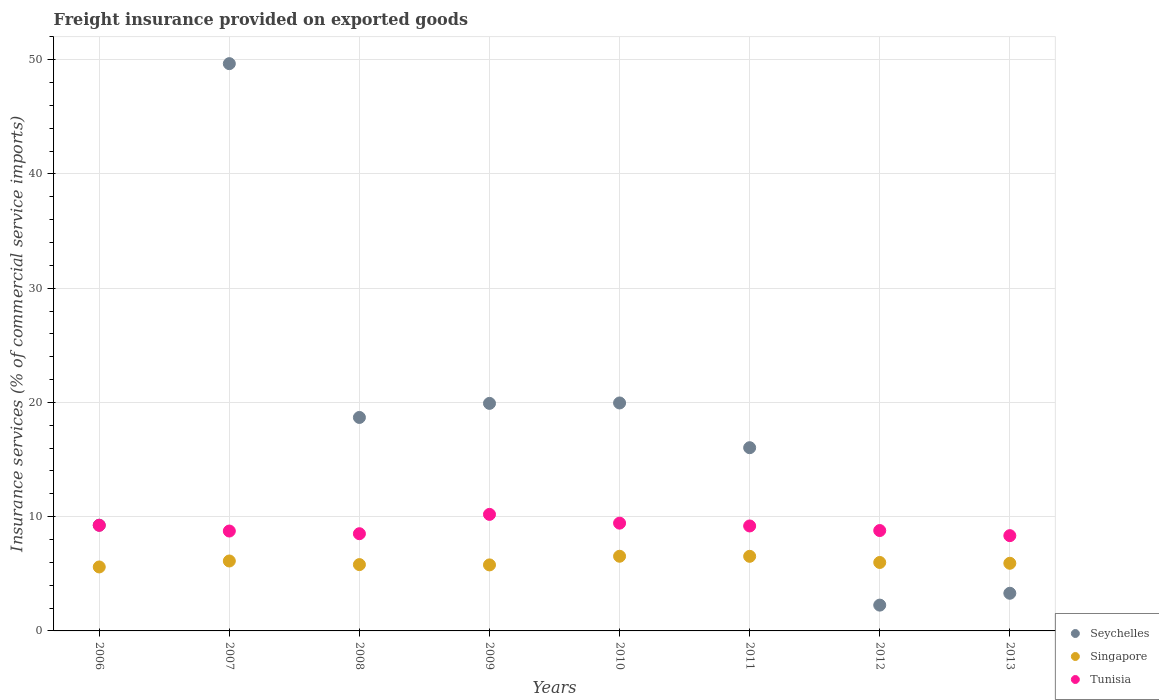How many different coloured dotlines are there?
Your answer should be very brief. 3. What is the freight insurance provided on exported goods in Singapore in 2008?
Provide a short and direct response. 5.81. Across all years, what is the maximum freight insurance provided on exported goods in Tunisia?
Offer a terse response. 10.2. Across all years, what is the minimum freight insurance provided on exported goods in Tunisia?
Offer a terse response. 8.34. What is the total freight insurance provided on exported goods in Singapore in the graph?
Your answer should be very brief. 48.29. What is the difference between the freight insurance provided on exported goods in Singapore in 2010 and that in 2011?
Offer a terse response. 0.01. What is the difference between the freight insurance provided on exported goods in Seychelles in 2011 and the freight insurance provided on exported goods in Singapore in 2010?
Offer a terse response. 9.5. What is the average freight insurance provided on exported goods in Tunisia per year?
Keep it short and to the point. 9.06. In the year 2012, what is the difference between the freight insurance provided on exported goods in Seychelles and freight insurance provided on exported goods in Tunisia?
Keep it short and to the point. -6.53. In how many years, is the freight insurance provided on exported goods in Singapore greater than 44 %?
Keep it short and to the point. 0. What is the ratio of the freight insurance provided on exported goods in Seychelles in 2007 to that in 2011?
Make the answer very short. 3.1. Is the freight insurance provided on exported goods in Seychelles in 2008 less than that in 2013?
Your answer should be very brief. No. Is the difference between the freight insurance provided on exported goods in Seychelles in 2006 and 2007 greater than the difference between the freight insurance provided on exported goods in Tunisia in 2006 and 2007?
Ensure brevity in your answer.  No. What is the difference between the highest and the second highest freight insurance provided on exported goods in Singapore?
Provide a succinct answer. 0.01. What is the difference between the highest and the lowest freight insurance provided on exported goods in Singapore?
Offer a terse response. 0.94. In how many years, is the freight insurance provided on exported goods in Tunisia greater than the average freight insurance provided on exported goods in Tunisia taken over all years?
Make the answer very short. 4. Is the sum of the freight insurance provided on exported goods in Singapore in 2009 and 2010 greater than the maximum freight insurance provided on exported goods in Seychelles across all years?
Provide a succinct answer. No. Does the freight insurance provided on exported goods in Seychelles monotonically increase over the years?
Provide a succinct answer. No. What is the difference between two consecutive major ticks on the Y-axis?
Provide a succinct answer. 10. Are the values on the major ticks of Y-axis written in scientific E-notation?
Your answer should be very brief. No. Does the graph contain grids?
Make the answer very short. Yes. How are the legend labels stacked?
Offer a very short reply. Vertical. What is the title of the graph?
Offer a terse response. Freight insurance provided on exported goods. Does "Curacao" appear as one of the legend labels in the graph?
Make the answer very short. No. What is the label or title of the X-axis?
Offer a very short reply. Years. What is the label or title of the Y-axis?
Your answer should be compact. Insurance services (% of commercial service imports). What is the Insurance services (% of commercial service imports) of Seychelles in 2006?
Provide a short and direct response. 9.26. What is the Insurance services (% of commercial service imports) of Singapore in 2006?
Your answer should be compact. 5.6. What is the Insurance services (% of commercial service imports) of Tunisia in 2006?
Provide a succinct answer. 9.25. What is the Insurance services (% of commercial service imports) in Seychelles in 2007?
Your response must be concise. 49.66. What is the Insurance services (% of commercial service imports) of Singapore in 2007?
Ensure brevity in your answer.  6.12. What is the Insurance services (% of commercial service imports) of Tunisia in 2007?
Offer a very short reply. 8.74. What is the Insurance services (% of commercial service imports) of Seychelles in 2008?
Give a very brief answer. 18.69. What is the Insurance services (% of commercial service imports) in Singapore in 2008?
Give a very brief answer. 5.81. What is the Insurance services (% of commercial service imports) of Tunisia in 2008?
Provide a succinct answer. 8.51. What is the Insurance services (% of commercial service imports) in Seychelles in 2009?
Your response must be concise. 19.92. What is the Insurance services (% of commercial service imports) in Singapore in 2009?
Keep it short and to the point. 5.78. What is the Insurance services (% of commercial service imports) of Tunisia in 2009?
Offer a terse response. 10.2. What is the Insurance services (% of commercial service imports) in Seychelles in 2010?
Your answer should be very brief. 19.96. What is the Insurance services (% of commercial service imports) in Singapore in 2010?
Make the answer very short. 6.54. What is the Insurance services (% of commercial service imports) of Tunisia in 2010?
Offer a terse response. 9.43. What is the Insurance services (% of commercial service imports) of Seychelles in 2011?
Offer a very short reply. 16.04. What is the Insurance services (% of commercial service imports) in Singapore in 2011?
Provide a succinct answer. 6.53. What is the Insurance services (% of commercial service imports) of Tunisia in 2011?
Provide a short and direct response. 9.19. What is the Insurance services (% of commercial service imports) of Seychelles in 2012?
Make the answer very short. 2.26. What is the Insurance services (% of commercial service imports) in Singapore in 2012?
Ensure brevity in your answer.  5.99. What is the Insurance services (% of commercial service imports) of Tunisia in 2012?
Provide a succinct answer. 8.79. What is the Insurance services (% of commercial service imports) of Seychelles in 2013?
Provide a succinct answer. 3.3. What is the Insurance services (% of commercial service imports) of Singapore in 2013?
Provide a succinct answer. 5.92. What is the Insurance services (% of commercial service imports) of Tunisia in 2013?
Give a very brief answer. 8.34. Across all years, what is the maximum Insurance services (% of commercial service imports) in Seychelles?
Make the answer very short. 49.66. Across all years, what is the maximum Insurance services (% of commercial service imports) of Singapore?
Make the answer very short. 6.54. Across all years, what is the maximum Insurance services (% of commercial service imports) in Tunisia?
Offer a very short reply. 10.2. Across all years, what is the minimum Insurance services (% of commercial service imports) of Seychelles?
Your answer should be very brief. 2.26. Across all years, what is the minimum Insurance services (% of commercial service imports) of Singapore?
Make the answer very short. 5.6. Across all years, what is the minimum Insurance services (% of commercial service imports) of Tunisia?
Your response must be concise. 8.34. What is the total Insurance services (% of commercial service imports) of Seychelles in the graph?
Ensure brevity in your answer.  139.08. What is the total Insurance services (% of commercial service imports) in Singapore in the graph?
Make the answer very short. 48.29. What is the total Insurance services (% of commercial service imports) in Tunisia in the graph?
Provide a succinct answer. 72.45. What is the difference between the Insurance services (% of commercial service imports) of Seychelles in 2006 and that in 2007?
Your answer should be very brief. -40.4. What is the difference between the Insurance services (% of commercial service imports) of Singapore in 2006 and that in 2007?
Provide a succinct answer. -0.52. What is the difference between the Insurance services (% of commercial service imports) of Tunisia in 2006 and that in 2007?
Offer a very short reply. 0.5. What is the difference between the Insurance services (% of commercial service imports) of Seychelles in 2006 and that in 2008?
Ensure brevity in your answer.  -9.43. What is the difference between the Insurance services (% of commercial service imports) of Singapore in 2006 and that in 2008?
Offer a very short reply. -0.21. What is the difference between the Insurance services (% of commercial service imports) in Tunisia in 2006 and that in 2008?
Provide a short and direct response. 0.74. What is the difference between the Insurance services (% of commercial service imports) of Seychelles in 2006 and that in 2009?
Offer a terse response. -10.66. What is the difference between the Insurance services (% of commercial service imports) in Singapore in 2006 and that in 2009?
Your answer should be very brief. -0.18. What is the difference between the Insurance services (% of commercial service imports) in Tunisia in 2006 and that in 2009?
Offer a very short reply. -0.96. What is the difference between the Insurance services (% of commercial service imports) in Seychelles in 2006 and that in 2010?
Provide a succinct answer. -10.7. What is the difference between the Insurance services (% of commercial service imports) in Singapore in 2006 and that in 2010?
Offer a very short reply. -0.94. What is the difference between the Insurance services (% of commercial service imports) of Tunisia in 2006 and that in 2010?
Make the answer very short. -0.19. What is the difference between the Insurance services (% of commercial service imports) of Seychelles in 2006 and that in 2011?
Ensure brevity in your answer.  -6.78. What is the difference between the Insurance services (% of commercial service imports) of Singapore in 2006 and that in 2011?
Your answer should be compact. -0.93. What is the difference between the Insurance services (% of commercial service imports) of Tunisia in 2006 and that in 2011?
Provide a succinct answer. 0.06. What is the difference between the Insurance services (% of commercial service imports) of Seychelles in 2006 and that in 2012?
Ensure brevity in your answer.  7. What is the difference between the Insurance services (% of commercial service imports) of Singapore in 2006 and that in 2012?
Your answer should be very brief. -0.39. What is the difference between the Insurance services (% of commercial service imports) of Tunisia in 2006 and that in 2012?
Make the answer very short. 0.46. What is the difference between the Insurance services (% of commercial service imports) of Seychelles in 2006 and that in 2013?
Offer a very short reply. 5.96. What is the difference between the Insurance services (% of commercial service imports) in Singapore in 2006 and that in 2013?
Your answer should be very brief. -0.32. What is the difference between the Insurance services (% of commercial service imports) of Tunisia in 2006 and that in 2013?
Keep it short and to the point. 0.91. What is the difference between the Insurance services (% of commercial service imports) of Seychelles in 2007 and that in 2008?
Your response must be concise. 30.97. What is the difference between the Insurance services (% of commercial service imports) in Singapore in 2007 and that in 2008?
Give a very brief answer. 0.32. What is the difference between the Insurance services (% of commercial service imports) of Tunisia in 2007 and that in 2008?
Keep it short and to the point. 0.23. What is the difference between the Insurance services (% of commercial service imports) in Seychelles in 2007 and that in 2009?
Your answer should be very brief. 29.74. What is the difference between the Insurance services (% of commercial service imports) of Singapore in 2007 and that in 2009?
Your answer should be compact. 0.34. What is the difference between the Insurance services (% of commercial service imports) in Tunisia in 2007 and that in 2009?
Make the answer very short. -1.46. What is the difference between the Insurance services (% of commercial service imports) of Seychelles in 2007 and that in 2010?
Ensure brevity in your answer.  29.7. What is the difference between the Insurance services (% of commercial service imports) of Singapore in 2007 and that in 2010?
Provide a succinct answer. -0.41. What is the difference between the Insurance services (% of commercial service imports) of Tunisia in 2007 and that in 2010?
Provide a succinct answer. -0.69. What is the difference between the Insurance services (% of commercial service imports) in Seychelles in 2007 and that in 2011?
Provide a succinct answer. 33.62. What is the difference between the Insurance services (% of commercial service imports) in Singapore in 2007 and that in 2011?
Offer a very short reply. -0.41. What is the difference between the Insurance services (% of commercial service imports) in Tunisia in 2007 and that in 2011?
Offer a terse response. -0.44. What is the difference between the Insurance services (% of commercial service imports) of Seychelles in 2007 and that in 2012?
Give a very brief answer. 47.4. What is the difference between the Insurance services (% of commercial service imports) in Singapore in 2007 and that in 2012?
Keep it short and to the point. 0.13. What is the difference between the Insurance services (% of commercial service imports) of Tunisia in 2007 and that in 2012?
Your answer should be very brief. -0.04. What is the difference between the Insurance services (% of commercial service imports) in Seychelles in 2007 and that in 2013?
Provide a succinct answer. 46.36. What is the difference between the Insurance services (% of commercial service imports) of Singapore in 2007 and that in 2013?
Make the answer very short. 0.2. What is the difference between the Insurance services (% of commercial service imports) of Tunisia in 2007 and that in 2013?
Your answer should be very brief. 0.4. What is the difference between the Insurance services (% of commercial service imports) in Seychelles in 2008 and that in 2009?
Provide a short and direct response. -1.23. What is the difference between the Insurance services (% of commercial service imports) of Singapore in 2008 and that in 2009?
Provide a succinct answer. 0.03. What is the difference between the Insurance services (% of commercial service imports) of Tunisia in 2008 and that in 2009?
Your response must be concise. -1.69. What is the difference between the Insurance services (% of commercial service imports) in Seychelles in 2008 and that in 2010?
Ensure brevity in your answer.  -1.27. What is the difference between the Insurance services (% of commercial service imports) of Singapore in 2008 and that in 2010?
Give a very brief answer. -0.73. What is the difference between the Insurance services (% of commercial service imports) of Tunisia in 2008 and that in 2010?
Your response must be concise. -0.92. What is the difference between the Insurance services (% of commercial service imports) in Seychelles in 2008 and that in 2011?
Your answer should be very brief. 2.65. What is the difference between the Insurance services (% of commercial service imports) of Singapore in 2008 and that in 2011?
Your answer should be very brief. -0.73. What is the difference between the Insurance services (% of commercial service imports) in Tunisia in 2008 and that in 2011?
Make the answer very short. -0.68. What is the difference between the Insurance services (% of commercial service imports) in Seychelles in 2008 and that in 2012?
Your answer should be compact. 16.43. What is the difference between the Insurance services (% of commercial service imports) of Singapore in 2008 and that in 2012?
Provide a succinct answer. -0.19. What is the difference between the Insurance services (% of commercial service imports) in Tunisia in 2008 and that in 2012?
Offer a terse response. -0.28. What is the difference between the Insurance services (% of commercial service imports) of Seychelles in 2008 and that in 2013?
Provide a succinct answer. 15.39. What is the difference between the Insurance services (% of commercial service imports) of Singapore in 2008 and that in 2013?
Provide a short and direct response. -0.12. What is the difference between the Insurance services (% of commercial service imports) of Tunisia in 2008 and that in 2013?
Give a very brief answer. 0.17. What is the difference between the Insurance services (% of commercial service imports) of Seychelles in 2009 and that in 2010?
Make the answer very short. -0.04. What is the difference between the Insurance services (% of commercial service imports) in Singapore in 2009 and that in 2010?
Your response must be concise. -0.76. What is the difference between the Insurance services (% of commercial service imports) of Tunisia in 2009 and that in 2010?
Keep it short and to the point. 0.77. What is the difference between the Insurance services (% of commercial service imports) of Seychelles in 2009 and that in 2011?
Ensure brevity in your answer.  3.88. What is the difference between the Insurance services (% of commercial service imports) of Singapore in 2009 and that in 2011?
Provide a succinct answer. -0.75. What is the difference between the Insurance services (% of commercial service imports) in Tunisia in 2009 and that in 2011?
Your response must be concise. 1.01. What is the difference between the Insurance services (% of commercial service imports) in Seychelles in 2009 and that in 2012?
Your answer should be compact. 17.66. What is the difference between the Insurance services (% of commercial service imports) of Singapore in 2009 and that in 2012?
Make the answer very short. -0.21. What is the difference between the Insurance services (% of commercial service imports) of Tunisia in 2009 and that in 2012?
Offer a terse response. 1.41. What is the difference between the Insurance services (% of commercial service imports) in Seychelles in 2009 and that in 2013?
Make the answer very short. 16.62. What is the difference between the Insurance services (% of commercial service imports) in Singapore in 2009 and that in 2013?
Make the answer very short. -0.14. What is the difference between the Insurance services (% of commercial service imports) of Tunisia in 2009 and that in 2013?
Your answer should be very brief. 1.86. What is the difference between the Insurance services (% of commercial service imports) of Seychelles in 2010 and that in 2011?
Ensure brevity in your answer.  3.92. What is the difference between the Insurance services (% of commercial service imports) in Singapore in 2010 and that in 2011?
Your response must be concise. 0.01. What is the difference between the Insurance services (% of commercial service imports) in Tunisia in 2010 and that in 2011?
Offer a terse response. 0.25. What is the difference between the Insurance services (% of commercial service imports) of Seychelles in 2010 and that in 2012?
Make the answer very short. 17.7. What is the difference between the Insurance services (% of commercial service imports) in Singapore in 2010 and that in 2012?
Give a very brief answer. 0.54. What is the difference between the Insurance services (% of commercial service imports) in Tunisia in 2010 and that in 2012?
Offer a very short reply. 0.65. What is the difference between the Insurance services (% of commercial service imports) in Seychelles in 2010 and that in 2013?
Your answer should be compact. 16.66. What is the difference between the Insurance services (% of commercial service imports) in Singapore in 2010 and that in 2013?
Offer a very short reply. 0.62. What is the difference between the Insurance services (% of commercial service imports) in Tunisia in 2010 and that in 2013?
Provide a succinct answer. 1.09. What is the difference between the Insurance services (% of commercial service imports) in Seychelles in 2011 and that in 2012?
Your response must be concise. 13.78. What is the difference between the Insurance services (% of commercial service imports) of Singapore in 2011 and that in 2012?
Offer a terse response. 0.54. What is the difference between the Insurance services (% of commercial service imports) of Tunisia in 2011 and that in 2012?
Make the answer very short. 0.4. What is the difference between the Insurance services (% of commercial service imports) of Seychelles in 2011 and that in 2013?
Offer a very short reply. 12.74. What is the difference between the Insurance services (% of commercial service imports) of Singapore in 2011 and that in 2013?
Provide a succinct answer. 0.61. What is the difference between the Insurance services (% of commercial service imports) in Tunisia in 2011 and that in 2013?
Ensure brevity in your answer.  0.85. What is the difference between the Insurance services (% of commercial service imports) of Seychelles in 2012 and that in 2013?
Your answer should be very brief. -1.04. What is the difference between the Insurance services (% of commercial service imports) of Singapore in 2012 and that in 2013?
Offer a terse response. 0.07. What is the difference between the Insurance services (% of commercial service imports) of Tunisia in 2012 and that in 2013?
Keep it short and to the point. 0.45. What is the difference between the Insurance services (% of commercial service imports) in Seychelles in 2006 and the Insurance services (% of commercial service imports) in Singapore in 2007?
Your answer should be very brief. 3.13. What is the difference between the Insurance services (% of commercial service imports) of Seychelles in 2006 and the Insurance services (% of commercial service imports) of Tunisia in 2007?
Offer a very short reply. 0.51. What is the difference between the Insurance services (% of commercial service imports) in Singapore in 2006 and the Insurance services (% of commercial service imports) in Tunisia in 2007?
Offer a terse response. -3.14. What is the difference between the Insurance services (% of commercial service imports) of Seychelles in 2006 and the Insurance services (% of commercial service imports) of Singapore in 2008?
Offer a terse response. 3.45. What is the difference between the Insurance services (% of commercial service imports) of Seychelles in 2006 and the Insurance services (% of commercial service imports) of Tunisia in 2008?
Give a very brief answer. 0.75. What is the difference between the Insurance services (% of commercial service imports) in Singapore in 2006 and the Insurance services (% of commercial service imports) in Tunisia in 2008?
Offer a terse response. -2.91. What is the difference between the Insurance services (% of commercial service imports) of Seychelles in 2006 and the Insurance services (% of commercial service imports) of Singapore in 2009?
Make the answer very short. 3.48. What is the difference between the Insurance services (% of commercial service imports) of Seychelles in 2006 and the Insurance services (% of commercial service imports) of Tunisia in 2009?
Give a very brief answer. -0.95. What is the difference between the Insurance services (% of commercial service imports) in Singapore in 2006 and the Insurance services (% of commercial service imports) in Tunisia in 2009?
Ensure brevity in your answer.  -4.6. What is the difference between the Insurance services (% of commercial service imports) of Seychelles in 2006 and the Insurance services (% of commercial service imports) of Singapore in 2010?
Your answer should be very brief. 2.72. What is the difference between the Insurance services (% of commercial service imports) of Seychelles in 2006 and the Insurance services (% of commercial service imports) of Tunisia in 2010?
Your response must be concise. -0.18. What is the difference between the Insurance services (% of commercial service imports) in Singapore in 2006 and the Insurance services (% of commercial service imports) in Tunisia in 2010?
Keep it short and to the point. -3.84. What is the difference between the Insurance services (% of commercial service imports) of Seychelles in 2006 and the Insurance services (% of commercial service imports) of Singapore in 2011?
Provide a short and direct response. 2.73. What is the difference between the Insurance services (% of commercial service imports) of Seychelles in 2006 and the Insurance services (% of commercial service imports) of Tunisia in 2011?
Offer a terse response. 0.07. What is the difference between the Insurance services (% of commercial service imports) in Singapore in 2006 and the Insurance services (% of commercial service imports) in Tunisia in 2011?
Make the answer very short. -3.59. What is the difference between the Insurance services (% of commercial service imports) of Seychelles in 2006 and the Insurance services (% of commercial service imports) of Singapore in 2012?
Your answer should be very brief. 3.26. What is the difference between the Insurance services (% of commercial service imports) in Seychelles in 2006 and the Insurance services (% of commercial service imports) in Tunisia in 2012?
Your response must be concise. 0.47. What is the difference between the Insurance services (% of commercial service imports) of Singapore in 2006 and the Insurance services (% of commercial service imports) of Tunisia in 2012?
Offer a terse response. -3.19. What is the difference between the Insurance services (% of commercial service imports) in Seychelles in 2006 and the Insurance services (% of commercial service imports) in Singapore in 2013?
Your answer should be very brief. 3.33. What is the difference between the Insurance services (% of commercial service imports) in Seychelles in 2006 and the Insurance services (% of commercial service imports) in Tunisia in 2013?
Give a very brief answer. 0.92. What is the difference between the Insurance services (% of commercial service imports) in Singapore in 2006 and the Insurance services (% of commercial service imports) in Tunisia in 2013?
Offer a very short reply. -2.74. What is the difference between the Insurance services (% of commercial service imports) of Seychelles in 2007 and the Insurance services (% of commercial service imports) of Singapore in 2008?
Give a very brief answer. 43.85. What is the difference between the Insurance services (% of commercial service imports) in Seychelles in 2007 and the Insurance services (% of commercial service imports) in Tunisia in 2008?
Provide a succinct answer. 41.15. What is the difference between the Insurance services (% of commercial service imports) in Singapore in 2007 and the Insurance services (% of commercial service imports) in Tunisia in 2008?
Your response must be concise. -2.39. What is the difference between the Insurance services (% of commercial service imports) of Seychelles in 2007 and the Insurance services (% of commercial service imports) of Singapore in 2009?
Give a very brief answer. 43.88. What is the difference between the Insurance services (% of commercial service imports) of Seychelles in 2007 and the Insurance services (% of commercial service imports) of Tunisia in 2009?
Provide a short and direct response. 39.46. What is the difference between the Insurance services (% of commercial service imports) of Singapore in 2007 and the Insurance services (% of commercial service imports) of Tunisia in 2009?
Your answer should be compact. -4.08. What is the difference between the Insurance services (% of commercial service imports) of Seychelles in 2007 and the Insurance services (% of commercial service imports) of Singapore in 2010?
Make the answer very short. 43.12. What is the difference between the Insurance services (% of commercial service imports) in Seychelles in 2007 and the Insurance services (% of commercial service imports) in Tunisia in 2010?
Provide a short and direct response. 40.23. What is the difference between the Insurance services (% of commercial service imports) in Singapore in 2007 and the Insurance services (% of commercial service imports) in Tunisia in 2010?
Keep it short and to the point. -3.31. What is the difference between the Insurance services (% of commercial service imports) in Seychelles in 2007 and the Insurance services (% of commercial service imports) in Singapore in 2011?
Your answer should be compact. 43.13. What is the difference between the Insurance services (% of commercial service imports) in Seychelles in 2007 and the Insurance services (% of commercial service imports) in Tunisia in 2011?
Make the answer very short. 40.47. What is the difference between the Insurance services (% of commercial service imports) of Singapore in 2007 and the Insurance services (% of commercial service imports) of Tunisia in 2011?
Provide a short and direct response. -3.07. What is the difference between the Insurance services (% of commercial service imports) of Seychelles in 2007 and the Insurance services (% of commercial service imports) of Singapore in 2012?
Your answer should be very brief. 43.67. What is the difference between the Insurance services (% of commercial service imports) of Seychelles in 2007 and the Insurance services (% of commercial service imports) of Tunisia in 2012?
Give a very brief answer. 40.87. What is the difference between the Insurance services (% of commercial service imports) of Singapore in 2007 and the Insurance services (% of commercial service imports) of Tunisia in 2012?
Your answer should be very brief. -2.67. What is the difference between the Insurance services (% of commercial service imports) in Seychelles in 2007 and the Insurance services (% of commercial service imports) in Singapore in 2013?
Your answer should be compact. 43.74. What is the difference between the Insurance services (% of commercial service imports) in Seychelles in 2007 and the Insurance services (% of commercial service imports) in Tunisia in 2013?
Offer a terse response. 41.32. What is the difference between the Insurance services (% of commercial service imports) in Singapore in 2007 and the Insurance services (% of commercial service imports) in Tunisia in 2013?
Your answer should be compact. -2.22. What is the difference between the Insurance services (% of commercial service imports) of Seychelles in 2008 and the Insurance services (% of commercial service imports) of Singapore in 2009?
Provide a short and direct response. 12.91. What is the difference between the Insurance services (% of commercial service imports) in Seychelles in 2008 and the Insurance services (% of commercial service imports) in Tunisia in 2009?
Make the answer very short. 8.49. What is the difference between the Insurance services (% of commercial service imports) of Singapore in 2008 and the Insurance services (% of commercial service imports) of Tunisia in 2009?
Keep it short and to the point. -4.4. What is the difference between the Insurance services (% of commercial service imports) of Seychelles in 2008 and the Insurance services (% of commercial service imports) of Singapore in 2010?
Your answer should be very brief. 12.15. What is the difference between the Insurance services (% of commercial service imports) of Seychelles in 2008 and the Insurance services (% of commercial service imports) of Tunisia in 2010?
Your answer should be very brief. 9.25. What is the difference between the Insurance services (% of commercial service imports) of Singapore in 2008 and the Insurance services (% of commercial service imports) of Tunisia in 2010?
Ensure brevity in your answer.  -3.63. What is the difference between the Insurance services (% of commercial service imports) in Seychelles in 2008 and the Insurance services (% of commercial service imports) in Singapore in 2011?
Your response must be concise. 12.16. What is the difference between the Insurance services (% of commercial service imports) of Seychelles in 2008 and the Insurance services (% of commercial service imports) of Tunisia in 2011?
Your answer should be very brief. 9.5. What is the difference between the Insurance services (% of commercial service imports) of Singapore in 2008 and the Insurance services (% of commercial service imports) of Tunisia in 2011?
Your answer should be compact. -3.38. What is the difference between the Insurance services (% of commercial service imports) in Seychelles in 2008 and the Insurance services (% of commercial service imports) in Singapore in 2012?
Keep it short and to the point. 12.7. What is the difference between the Insurance services (% of commercial service imports) of Seychelles in 2008 and the Insurance services (% of commercial service imports) of Tunisia in 2012?
Give a very brief answer. 9.9. What is the difference between the Insurance services (% of commercial service imports) in Singapore in 2008 and the Insurance services (% of commercial service imports) in Tunisia in 2012?
Offer a very short reply. -2.98. What is the difference between the Insurance services (% of commercial service imports) of Seychelles in 2008 and the Insurance services (% of commercial service imports) of Singapore in 2013?
Your response must be concise. 12.77. What is the difference between the Insurance services (% of commercial service imports) of Seychelles in 2008 and the Insurance services (% of commercial service imports) of Tunisia in 2013?
Provide a succinct answer. 10.35. What is the difference between the Insurance services (% of commercial service imports) of Singapore in 2008 and the Insurance services (% of commercial service imports) of Tunisia in 2013?
Your response must be concise. -2.53. What is the difference between the Insurance services (% of commercial service imports) of Seychelles in 2009 and the Insurance services (% of commercial service imports) of Singapore in 2010?
Ensure brevity in your answer.  13.38. What is the difference between the Insurance services (% of commercial service imports) in Seychelles in 2009 and the Insurance services (% of commercial service imports) in Tunisia in 2010?
Your answer should be very brief. 10.48. What is the difference between the Insurance services (% of commercial service imports) of Singapore in 2009 and the Insurance services (% of commercial service imports) of Tunisia in 2010?
Offer a terse response. -3.66. What is the difference between the Insurance services (% of commercial service imports) of Seychelles in 2009 and the Insurance services (% of commercial service imports) of Singapore in 2011?
Give a very brief answer. 13.39. What is the difference between the Insurance services (% of commercial service imports) of Seychelles in 2009 and the Insurance services (% of commercial service imports) of Tunisia in 2011?
Offer a terse response. 10.73. What is the difference between the Insurance services (% of commercial service imports) in Singapore in 2009 and the Insurance services (% of commercial service imports) in Tunisia in 2011?
Keep it short and to the point. -3.41. What is the difference between the Insurance services (% of commercial service imports) in Seychelles in 2009 and the Insurance services (% of commercial service imports) in Singapore in 2012?
Your response must be concise. 13.93. What is the difference between the Insurance services (% of commercial service imports) of Seychelles in 2009 and the Insurance services (% of commercial service imports) of Tunisia in 2012?
Offer a very short reply. 11.13. What is the difference between the Insurance services (% of commercial service imports) of Singapore in 2009 and the Insurance services (% of commercial service imports) of Tunisia in 2012?
Provide a short and direct response. -3.01. What is the difference between the Insurance services (% of commercial service imports) in Seychelles in 2009 and the Insurance services (% of commercial service imports) in Singapore in 2013?
Provide a short and direct response. 14. What is the difference between the Insurance services (% of commercial service imports) of Seychelles in 2009 and the Insurance services (% of commercial service imports) of Tunisia in 2013?
Provide a short and direct response. 11.58. What is the difference between the Insurance services (% of commercial service imports) in Singapore in 2009 and the Insurance services (% of commercial service imports) in Tunisia in 2013?
Keep it short and to the point. -2.56. What is the difference between the Insurance services (% of commercial service imports) of Seychelles in 2010 and the Insurance services (% of commercial service imports) of Singapore in 2011?
Make the answer very short. 13.43. What is the difference between the Insurance services (% of commercial service imports) in Seychelles in 2010 and the Insurance services (% of commercial service imports) in Tunisia in 2011?
Make the answer very short. 10.77. What is the difference between the Insurance services (% of commercial service imports) of Singapore in 2010 and the Insurance services (% of commercial service imports) of Tunisia in 2011?
Give a very brief answer. -2.65. What is the difference between the Insurance services (% of commercial service imports) of Seychelles in 2010 and the Insurance services (% of commercial service imports) of Singapore in 2012?
Ensure brevity in your answer.  13.96. What is the difference between the Insurance services (% of commercial service imports) in Seychelles in 2010 and the Insurance services (% of commercial service imports) in Tunisia in 2012?
Provide a short and direct response. 11.17. What is the difference between the Insurance services (% of commercial service imports) of Singapore in 2010 and the Insurance services (% of commercial service imports) of Tunisia in 2012?
Give a very brief answer. -2.25. What is the difference between the Insurance services (% of commercial service imports) of Seychelles in 2010 and the Insurance services (% of commercial service imports) of Singapore in 2013?
Your answer should be compact. 14.03. What is the difference between the Insurance services (% of commercial service imports) of Seychelles in 2010 and the Insurance services (% of commercial service imports) of Tunisia in 2013?
Offer a very short reply. 11.62. What is the difference between the Insurance services (% of commercial service imports) of Singapore in 2010 and the Insurance services (% of commercial service imports) of Tunisia in 2013?
Your answer should be very brief. -1.8. What is the difference between the Insurance services (% of commercial service imports) of Seychelles in 2011 and the Insurance services (% of commercial service imports) of Singapore in 2012?
Provide a short and direct response. 10.05. What is the difference between the Insurance services (% of commercial service imports) of Seychelles in 2011 and the Insurance services (% of commercial service imports) of Tunisia in 2012?
Give a very brief answer. 7.25. What is the difference between the Insurance services (% of commercial service imports) of Singapore in 2011 and the Insurance services (% of commercial service imports) of Tunisia in 2012?
Give a very brief answer. -2.26. What is the difference between the Insurance services (% of commercial service imports) of Seychelles in 2011 and the Insurance services (% of commercial service imports) of Singapore in 2013?
Offer a terse response. 10.12. What is the difference between the Insurance services (% of commercial service imports) of Seychelles in 2011 and the Insurance services (% of commercial service imports) of Tunisia in 2013?
Ensure brevity in your answer.  7.7. What is the difference between the Insurance services (% of commercial service imports) of Singapore in 2011 and the Insurance services (% of commercial service imports) of Tunisia in 2013?
Make the answer very short. -1.81. What is the difference between the Insurance services (% of commercial service imports) of Seychelles in 2012 and the Insurance services (% of commercial service imports) of Singapore in 2013?
Ensure brevity in your answer.  -3.66. What is the difference between the Insurance services (% of commercial service imports) in Seychelles in 2012 and the Insurance services (% of commercial service imports) in Tunisia in 2013?
Your answer should be very brief. -6.08. What is the difference between the Insurance services (% of commercial service imports) of Singapore in 2012 and the Insurance services (% of commercial service imports) of Tunisia in 2013?
Ensure brevity in your answer.  -2.35. What is the average Insurance services (% of commercial service imports) in Seychelles per year?
Ensure brevity in your answer.  17.38. What is the average Insurance services (% of commercial service imports) in Singapore per year?
Your answer should be compact. 6.04. What is the average Insurance services (% of commercial service imports) of Tunisia per year?
Offer a very short reply. 9.06. In the year 2006, what is the difference between the Insurance services (% of commercial service imports) in Seychelles and Insurance services (% of commercial service imports) in Singapore?
Offer a terse response. 3.66. In the year 2006, what is the difference between the Insurance services (% of commercial service imports) in Seychelles and Insurance services (% of commercial service imports) in Tunisia?
Your response must be concise. 0.01. In the year 2006, what is the difference between the Insurance services (% of commercial service imports) of Singapore and Insurance services (% of commercial service imports) of Tunisia?
Keep it short and to the point. -3.65. In the year 2007, what is the difference between the Insurance services (% of commercial service imports) in Seychelles and Insurance services (% of commercial service imports) in Singapore?
Your response must be concise. 43.54. In the year 2007, what is the difference between the Insurance services (% of commercial service imports) of Seychelles and Insurance services (% of commercial service imports) of Tunisia?
Provide a succinct answer. 40.92. In the year 2007, what is the difference between the Insurance services (% of commercial service imports) of Singapore and Insurance services (% of commercial service imports) of Tunisia?
Provide a succinct answer. -2.62. In the year 2008, what is the difference between the Insurance services (% of commercial service imports) in Seychelles and Insurance services (% of commercial service imports) in Singapore?
Your response must be concise. 12.88. In the year 2008, what is the difference between the Insurance services (% of commercial service imports) in Seychelles and Insurance services (% of commercial service imports) in Tunisia?
Make the answer very short. 10.18. In the year 2008, what is the difference between the Insurance services (% of commercial service imports) in Singapore and Insurance services (% of commercial service imports) in Tunisia?
Ensure brevity in your answer.  -2.7. In the year 2009, what is the difference between the Insurance services (% of commercial service imports) in Seychelles and Insurance services (% of commercial service imports) in Singapore?
Ensure brevity in your answer.  14.14. In the year 2009, what is the difference between the Insurance services (% of commercial service imports) of Seychelles and Insurance services (% of commercial service imports) of Tunisia?
Your response must be concise. 9.72. In the year 2009, what is the difference between the Insurance services (% of commercial service imports) of Singapore and Insurance services (% of commercial service imports) of Tunisia?
Your answer should be very brief. -4.42. In the year 2010, what is the difference between the Insurance services (% of commercial service imports) in Seychelles and Insurance services (% of commercial service imports) in Singapore?
Ensure brevity in your answer.  13.42. In the year 2010, what is the difference between the Insurance services (% of commercial service imports) of Seychelles and Insurance services (% of commercial service imports) of Tunisia?
Provide a succinct answer. 10.52. In the year 2010, what is the difference between the Insurance services (% of commercial service imports) in Singapore and Insurance services (% of commercial service imports) in Tunisia?
Your answer should be compact. -2.9. In the year 2011, what is the difference between the Insurance services (% of commercial service imports) in Seychelles and Insurance services (% of commercial service imports) in Singapore?
Your response must be concise. 9.51. In the year 2011, what is the difference between the Insurance services (% of commercial service imports) in Seychelles and Insurance services (% of commercial service imports) in Tunisia?
Provide a succinct answer. 6.85. In the year 2011, what is the difference between the Insurance services (% of commercial service imports) in Singapore and Insurance services (% of commercial service imports) in Tunisia?
Give a very brief answer. -2.66. In the year 2012, what is the difference between the Insurance services (% of commercial service imports) in Seychelles and Insurance services (% of commercial service imports) in Singapore?
Your answer should be compact. -3.73. In the year 2012, what is the difference between the Insurance services (% of commercial service imports) of Seychelles and Insurance services (% of commercial service imports) of Tunisia?
Offer a very short reply. -6.53. In the year 2012, what is the difference between the Insurance services (% of commercial service imports) in Singapore and Insurance services (% of commercial service imports) in Tunisia?
Your answer should be very brief. -2.79. In the year 2013, what is the difference between the Insurance services (% of commercial service imports) of Seychelles and Insurance services (% of commercial service imports) of Singapore?
Offer a very short reply. -2.63. In the year 2013, what is the difference between the Insurance services (% of commercial service imports) of Seychelles and Insurance services (% of commercial service imports) of Tunisia?
Offer a very short reply. -5.04. In the year 2013, what is the difference between the Insurance services (% of commercial service imports) of Singapore and Insurance services (% of commercial service imports) of Tunisia?
Make the answer very short. -2.42. What is the ratio of the Insurance services (% of commercial service imports) of Seychelles in 2006 to that in 2007?
Offer a terse response. 0.19. What is the ratio of the Insurance services (% of commercial service imports) of Singapore in 2006 to that in 2007?
Your response must be concise. 0.91. What is the ratio of the Insurance services (% of commercial service imports) in Tunisia in 2006 to that in 2007?
Offer a very short reply. 1.06. What is the ratio of the Insurance services (% of commercial service imports) in Seychelles in 2006 to that in 2008?
Your response must be concise. 0.5. What is the ratio of the Insurance services (% of commercial service imports) of Singapore in 2006 to that in 2008?
Keep it short and to the point. 0.96. What is the ratio of the Insurance services (% of commercial service imports) in Tunisia in 2006 to that in 2008?
Make the answer very short. 1.09. What is the ratio of the Insurance services (% of commercial service imports) in Seychelles in 2006 to that in 2009?
Keep it short and to the point. 0.46. What is the ratio of the Insurance services (% of commercial service imports) of Singapore in 2006 to that in 2009?
Offer a terse response. 0.97. What is the ratio of the Insurance services (% of commercial service imports) in Tunisia in 2006 to that in 2009?
Make the answer very short. 0.91. What is the ratio of the Insurance services (% of commercial service imports) of Seychelles in 2006 to that in 2010?
Ensure brevity in your answer.  0.46. What is the ratio of the Insurance services (% of commercial service imports) in Singapore in 2006 to that in 2010?
Your answer should be very brief. 0.86. What is the ratio of the Insurance services (% of commercial service imports) in Tunisia in 2006 to that in 2010?
Your response must be concise. 0.98. What is the ratio of the Insurance services (% of commercial service imports) of Seychelles in 2006 to that in 2011?
Offer a terse response. 0.58. What is the ratio of the Insurance services (% of commercial service imports) in Singapore in 2006 to that in 2011?
Give a very brief answer. 0.86. What is the ratio of the Insurance services (% of commercial service imports) of Seychelles in 2006 to that in 2012?
Your answer should be very brief. 4.1. What is the ratio of the Insurance services (% of commercial service imports) in Singapore in 2006 to that in 2012?
Provide a succinct answer. 0.93. What is the ratio of the Insurance services (% of commercial service imports) in Tunisia in 2006 to that in 2012?
Your answer should be compact. 1.05. What is the ratio of the Insurance services (% of commercial service imports) of Seychelles in 2006 to that in 2013?
Keep it short and to the point. 2.81. What is the ratio of the Insurance services (% of commercial service imports) in Singapore in 2006 to that in 2013?
Your answer should be very brief. 0.95. What is the ratio of the Insurance services (% of commercial service imports) in Tunisia in 2006 to that in 2013?
Ensure brevity in your answer.  1.11. What is the ratio of the Insurance services (% of commercial service imports) of Seychelles in 2007 to that in 2008?
Provide a short and direct response. 2.66. What is the ratio of the Insurance services (% of commercial service imports) in Singapore in 2007 to that in 2008?
Give a very brief answer. 1.05. What is the ratio of the Insurance services (% of commercial service imports) in Tunisia in 2007 to that in 2008?
Keep it short and to the point. 1.03. What is the ratio of the Insurance services (% of commercial service imports) in Seychelles in 2007 to that in 2009?
Provide a short and direct response. 2.49. What is the ratio of the Insurance services (% of commercial service imports) of Singapore in 2007 to that in 2009?
Your answer should be compact. 1.06. What is the ratio of the Insurance services (% of commercial service imports) of Tunisia in 2007 to that in 2009?
Keep it short and to the point. 0.86. What is the ratio of the Insurance services (% of commercial service imports) in Seychelles in 2007 to that in 2010?
Offer a terse response. 2.49. What is the ratio of the Insurance services (% of commercial service imports) of Singapore in 2007 to that in 2010?
Offer a terse response. 0.94. What is the ratio of the Insurance services (% of commercial service imports) in Tunisia in 2007 to that in 2010?
Offer a terse response. 0.93. What is the ratio of the Insurance services (% of commercial service imports) in Seychelles in 2007 to that in 2011?
Make the answer very short. 3.1. What is the ratio of the Insurance services (% of commercial service imports) of Singapore in 2007 to that in 2011?
Provide a short and direct response. 0.94. What is the ratio of the Insurance services (% of commercial service imports) in Tunisia in 2007 to that in 2011?
Give a very brief answer. 0.95. What is the ratio of the Insurance services (% of commercial service imports) of Seychelles in 2007 to that in 2012?
Give a very brief answer. 21.99. What is the ratio of the Insurance services (% of commercial service imports) of Singapore in 2007 to that in 2012?
Your answer should be very brief. 1.02. What is the ratio of the Insurance services (% of commercial service imports) in Seychelles in 2007 to that in 2013?
Make the answer very short. 15.06. What is the ratio of the Insurance services (% of commercial service imports) of Singapore in 2007 to that in 2013?
Provide a succinct answer. 1.03. What is the ratio of the Insurance services (% of commercial service imports) of Tunisia in 2007 to that in 2013?
Give a very brief answer. 1.05. What is the ratio of the Insurance services (% of commercial service imports) in Seychelles in 2008 to that in 2009?
Provide a succinct answer. 0.94. What is the ratio of the Insurance services (% of commercial service imports) in Singapore in 2008 to that in 2009?
Give a very brief answer. 1. What is the ratio of the Insurance services (% of commercial service imports) in Tunisia in 2008 to that in 2009?
Your answer should be compact. 0.83. What is the ratio of the Insurance services (% of commercial service imports) of Seychelles in 2008 to that in 2010?
Make the answer very short. 0.94. What is the ratio of the Insurance services (% of commercial service imports) of Singapore in 2008 to that in 2010?
Make the answer very short. 0.89. What is the ratio of the Insurance services (% of commercial service imports) of Tunisia in 2008 to that in 2010?
Your answer should be compact. 0.9. What is the ratio of the Insurance services (% of commercial service imports) of Seychelles in 2008 to that in 2011?
Provide a short and direct response. 1.17. What is the ratio of the Insurance services (% of commercial service imports) of Singapore in 2008 to that in 2011?
Provide a succinct answer. 0.89. What is the ratio of the Insurance services (% of commercial service imports) in Tunisia in 2008 to that in 2011?
Offer a very short reply. 0.93. What is the ratio of the Insurance services (% of commercial service imports) of Seychelles in 2008 to that in 2012?
Ensure brevity in your answer.  8.27. What is the ratio of the Insurance services (% of commercial service imports) of Singapore in 2008 to that in 2012?
Your answer should be compact. 0.97. What is the ratio of the Insurance services (% of commercial service imports) in Tunisia in 2008 to that in 2012?
Make the answer very short. 0.97. What is the ratio of the Insurance services (% of commercial service imports) in Seychelles in 2008 to that in 2013?
Keep it short and to the point. 5.67. What is the ratio of the Insurance services (% of commercial service imports) of Singapore in 2008 to that in 2013?
Your answer should be compact. 0.98. What is the ratio of the Insurance services (% of commercial service imports) of Tunisia in 2008 to that in 2013?
Offer a terse response. 1.02. What is the ratio of the Insurance services (% of commercial service imports) in Seychelles in 2009 to that in 2010?
Provide a short and direct response. 1. What is the ratio of the Insurance services (% of commercial service imports) of Singapore in 2009 to that in 2010?
Keep it short and to the point. 0.88. What is the ratio of the Insurance services (% of commercial service imports) in Tunisia in 2009 to that in 2010?
Provide a short and direct response. 1.08. What is the ratio of the Insurance services (% of commercial service imports) of Seychelles in 2009 to that in 2011?
Your response must be concise. 1.24. What is the ratio of the Insurance services (% of commercial service imports) of Singapore in 2009 to that in 2011?
Make the answer very short. 0.89. What is the ratio of the Insurance services (% of commercial service imports) in Tunisia in 2009 to that in 2011?
Your answer should be compact. 1.11. What is the ratio of the Insurance services (% of commercial service imports) of Seychelles in 2009 to that in 2012?
Your response must be concise. 8.82. What is the ratio of the Insurance services (% of commercial service imports) in Singapore in 2009 to that in 2012?
Your answer should be compact. 0.96. What is the ratio of the Insurance services (% of commercial service imports) in Tunisia in 2009 to that in 2012?
Your answer should be compact. 1.16. What is the ratio of the Insurance services (% of commercial service imports) of Seychelles in 2009 to that in 2013?
Ensure brevity in your answer.  6.04. What is the ratio of the Insurance services (% of commercial service imports) in Singapore in 2009 to that in 2013?
Provide a short and direct response. 0.98. What is the ratio of the Insurance services (% of commercial service imports) of Tunisia in 2009 to that in 2013?
Offer a very short reply. 1.22. What is the ratio of the Insurance services (% of commercial service imports) of Seychelles in 2010 to that in 2011?
Give a very brief answer. 1.24. What is the ratio of the Insurance services (% of commercial service imports) of Tunisia in 2010 to that in 2011?
Offer a very short reply. 1.03. What is the ratio of the Insurance services (% of commercial service imports) of Seychelles in 2010 to that in 2012?
Give a very brief answer. 8.84. What is the ratio of the Insurance services (% of commercial service imports) in Singapore in 2010 to that in 2012?
Your answer should be compact. 1.09. What is the ratio of the Insurance services (% of commercial service imports) in Tunisia in 2010 to that in 2012?
Your answer should be compact. 1.07. What is the ratio of the Insurance services (% of commercial service imports) of Seychelles in 2010 to that in 2013?
Offer a terse response. 6.05. What is the ratio of the Insurance services (% of commercial service imports) in Singapore in 2010 to that in 2013?
Give a very brief answer. 1.1. What is the ratio of the Insurance services (% of commercial service imports) in Tunisia in 2010 to that in 2013?
Your answer should be very brief. 1.13. What is the ratio of the Insurance services (% of commercial service imports) in Seychelles in 2011 to that in 2012?
Offer a very short reply. 7.1. What is the ratio of the Insurance services (% of commercial service imports) in Singapore in 2011 to that in 2012?
Provide a short and direct response. 1.09. What is the ratio of the Insurance services (% of commercial service imports) in Tunisia in 2011 to that in 2012?
Make the answer very short. 1.05. What is the ratio of the Insurance services (% of commercial service imports) of Seychelles in 2011 to that in 2013?
Your answer should be very brief. 4.87. What is the ratio of the Insurance services (% of commercial service imports) in Singapore in 2011 to that in 2013?
Your response must be concise. 1.1. What is the ratio of the Insurance services (% of commercial service imports) in Tunisia in 2011 to that in 2013?
Ensure brevity in your answer.  1.1. What is the ratio of the Insurance services (% of commercial service imports) in Seychelles in 2012 to that in 2013?
Your response must be concise. 0.69. What is the ratio of the Insurance services (% of commercial service imports) in Singapore in 2012 to that in 2013?
Offer a terse response. 1.01. What is the ratio of the Insurance services (% of commercial service imports) of Tunisia in 2012 to that in 2013?
Make the answer very short. 1.05. What is the difference between the highest and the second highest Insurance services (% of commercial service imports) of Seychelles?
Provide a succinct answer. 29.7. What is the difference between the highest and the second highest Insurance services (% of commercial service imports) in Singapore?
Your answer should be compact. 0.01. What is the difference between the highest and the second highest Insurance services (% of commercial service imports) of Tunisia?
Offer a very short reply. 0.77. What is the difference between the highest and the lowest Insurance services (% of commercial service imports) in Seychelles?
Your answer should be compact. 47.4. What is the difference between the highest and the lowest Insurance services (% of commercial service imports) in Singapore?
Make the answer very short. 0.94. What is the difference between the highest and the lowest Insurance services (% of commercial service imports) of Tunisia?
Your answer should be compact. 1.86. 